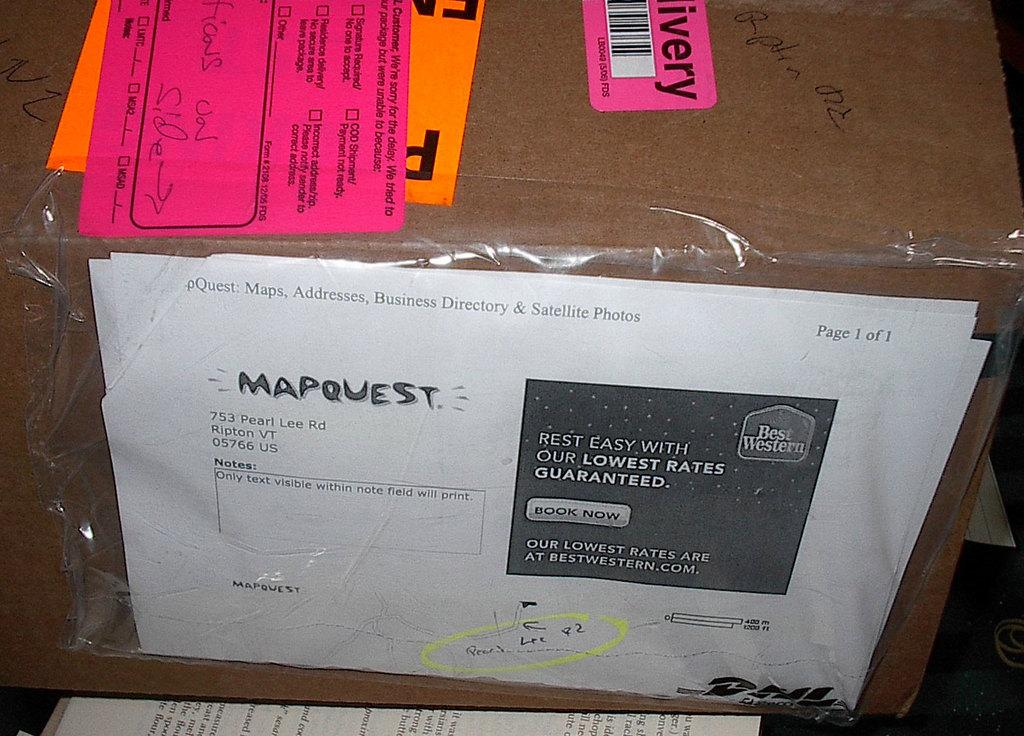Provide a one-sentence caption for the provided image. A box has a Mapquest printout attached to it. 